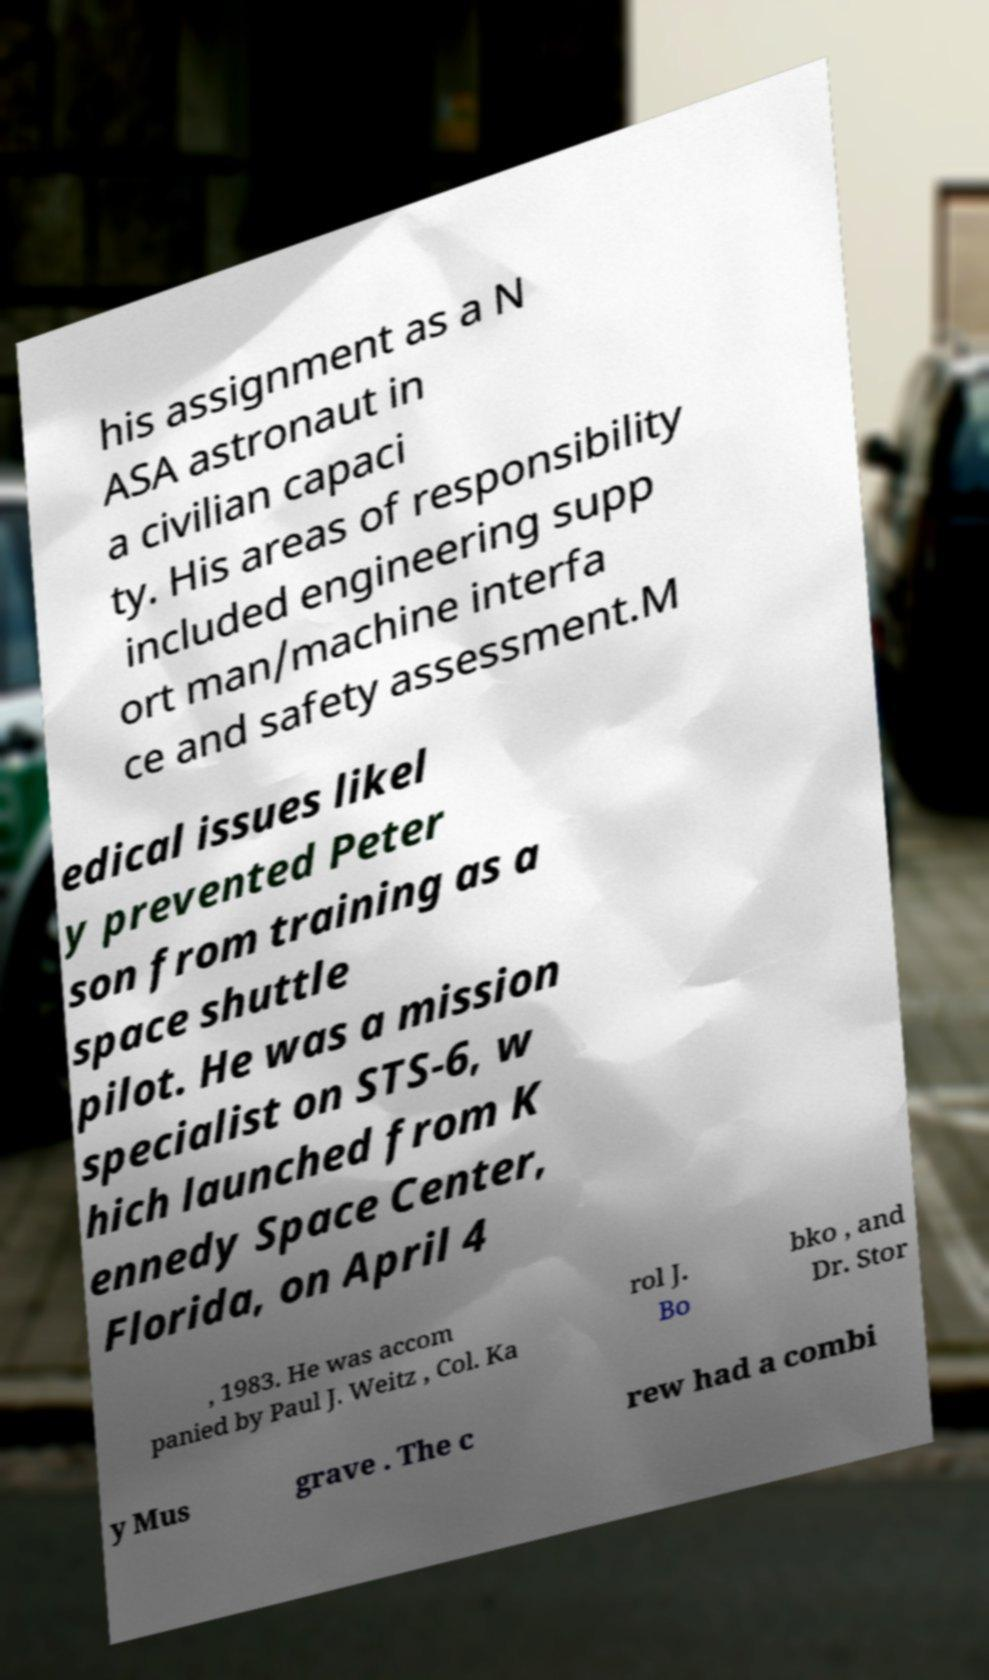Could you assist in decoding the text presented in this image and type it out clearly? his assignment as a N ASA astronaut in a civilian capaci ty. His areas of responsibility included engineering supp ort man/machine interfa ce and safety assessment.M edical issues likel y prevented Peter son from training as a space shuttle pilot. He was a mission specialist on STS-6, w hich launched from K ennedy Space Center, Florida, on April 4 , 1983. He was accom panied by Paul J. Weitz , Col. Ka rol J. Bo bko , and Dr. Stor y Mus grave . The c rew had a combi 